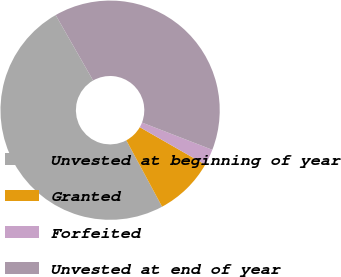Convert chart to OTSL. <chart><loc_0><loc_0><loc_500><loc_500><pie_chart><fcel>Unvested at beginning of year<fcel>Granted<fcel>Forfeited<fcel>Unvested at end of year<nl><fcel>49.59%<fcel>8.86%<fcel>2.39%<fcel>39.15%<nl></chart> 